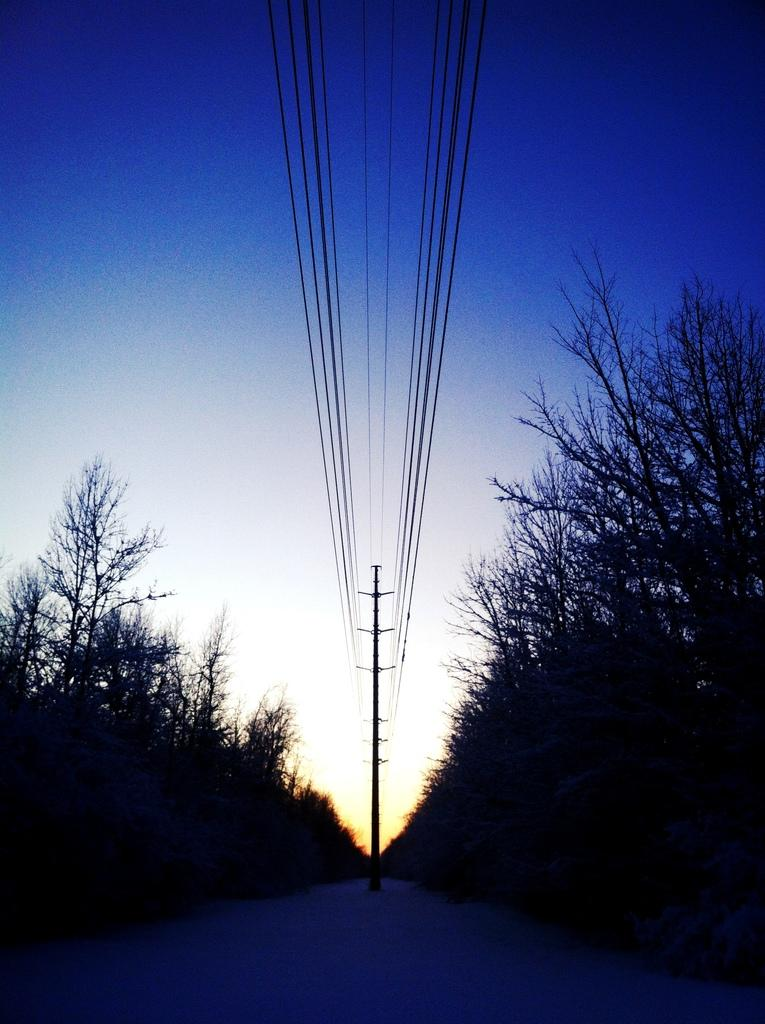What is the overall lighting condition in the image? The image is dark. What type of vegetation can be seen on both sides of the image? There are trees on either side of the image. What is located in the center of the image? There is a pole in the center of the image. What else can be seen in the image besides the trees and pole? There are wires visible in the image. What color is the sky visible at the top of the image? The sky is blue and visible at the top of the image. Can you see the daughter playing with the brain in the image? There is no daughter or brain present in the image. What type of bite is the pole taking in the image? The pole is not taking a bite in the image; it is a stationary object. 